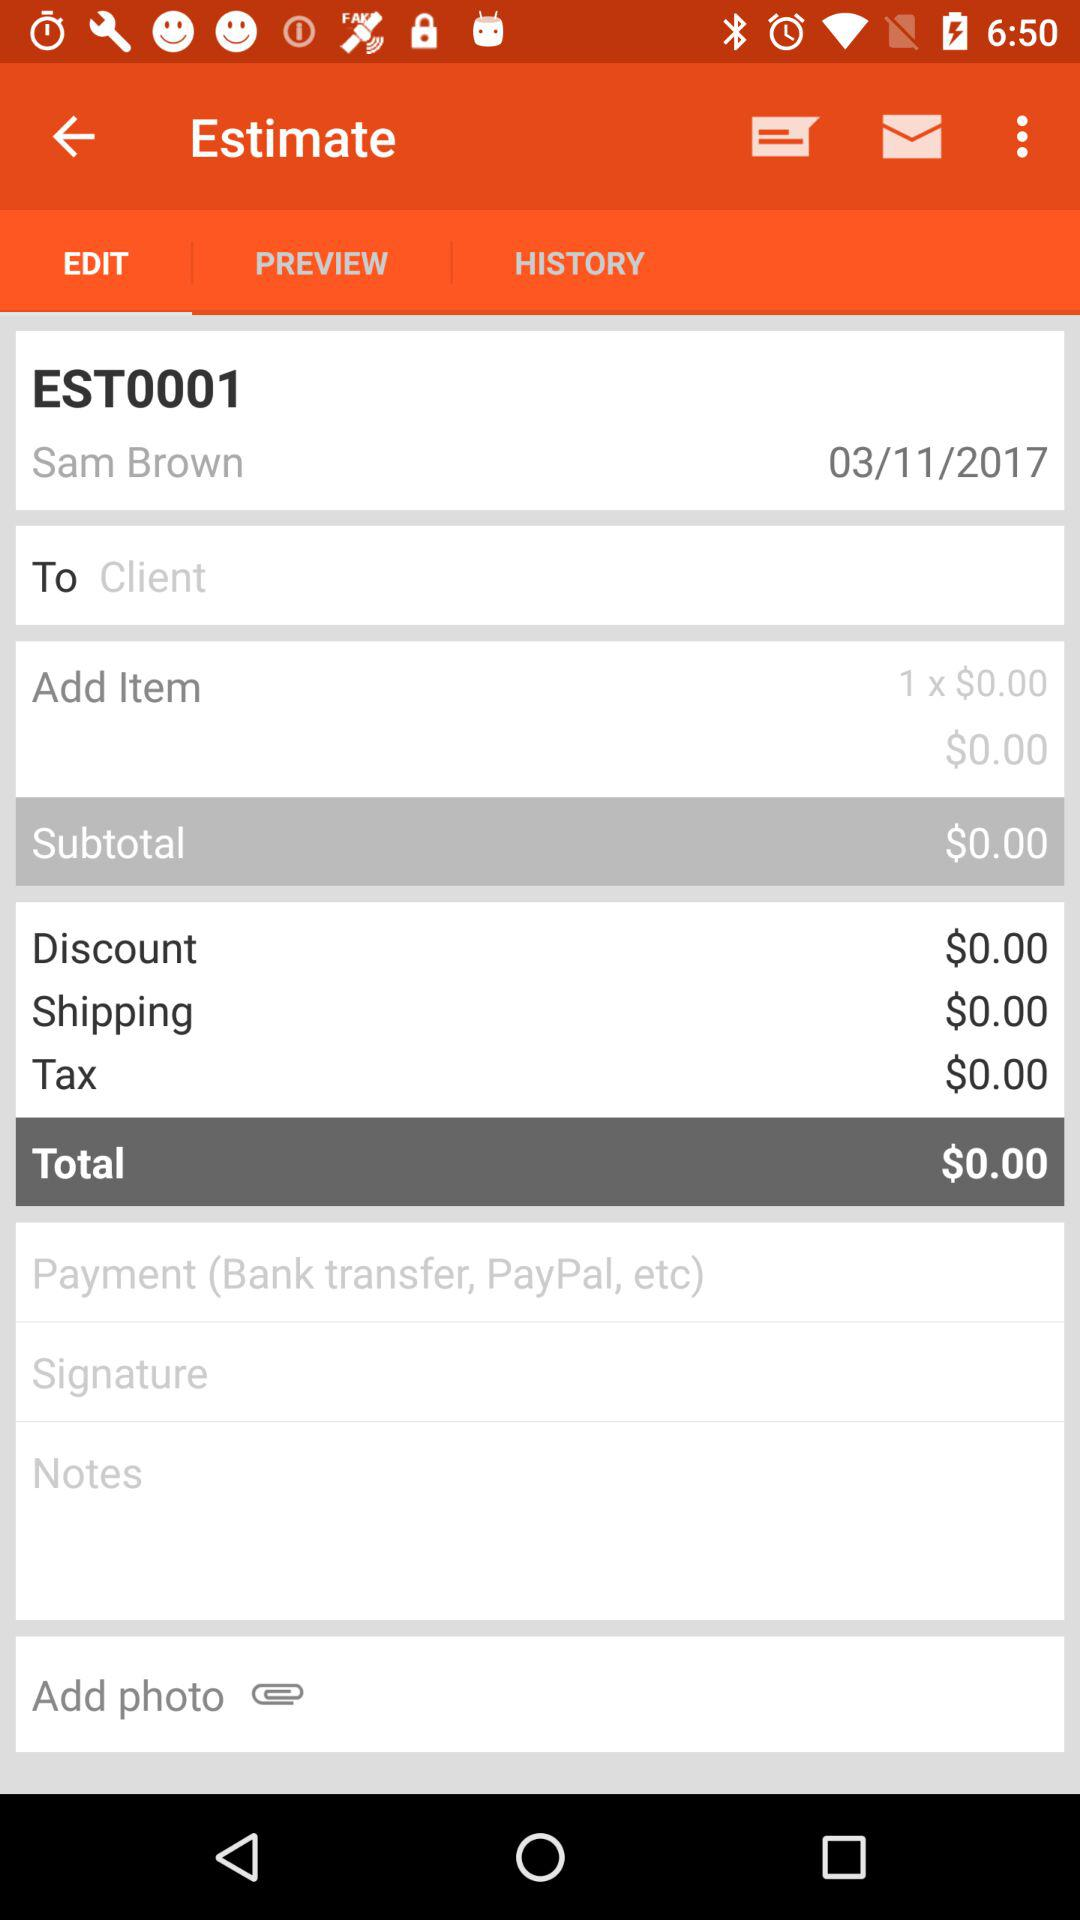What is the total amount of the shipping?
Answer the question using a single word or phrase. $0.00 